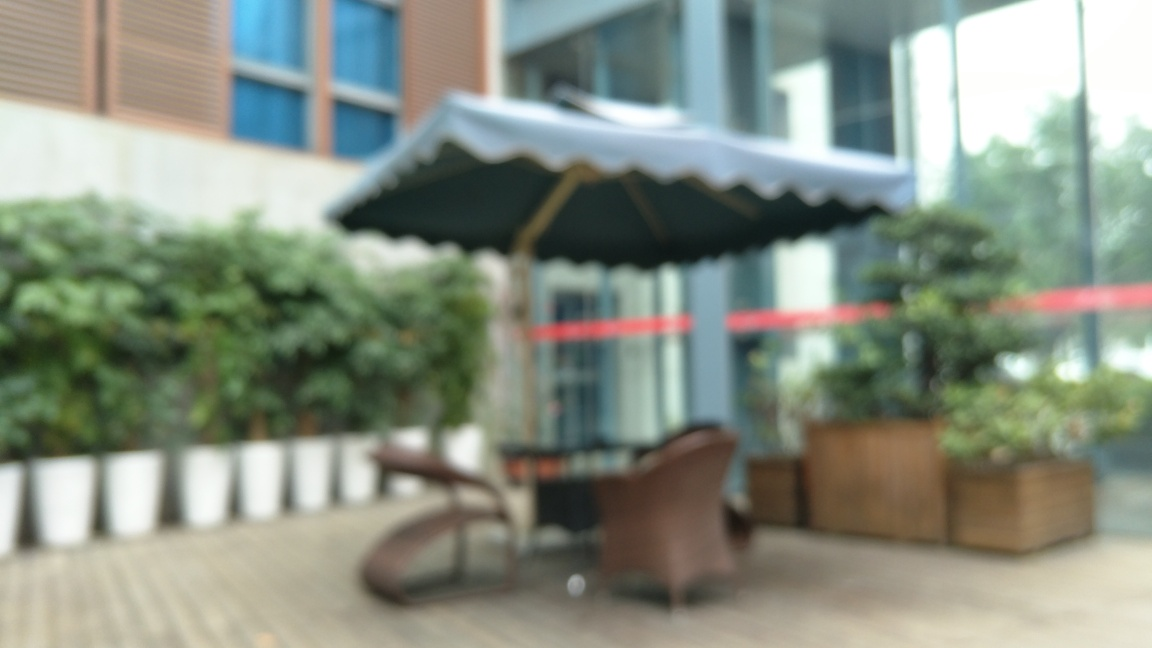What time of day does this photo seem to depict? Based on the ambient lighting and the shadows present, it might suggest late afternoon or early evening, but the exact time is indeterminate given the blurriness of the image. 